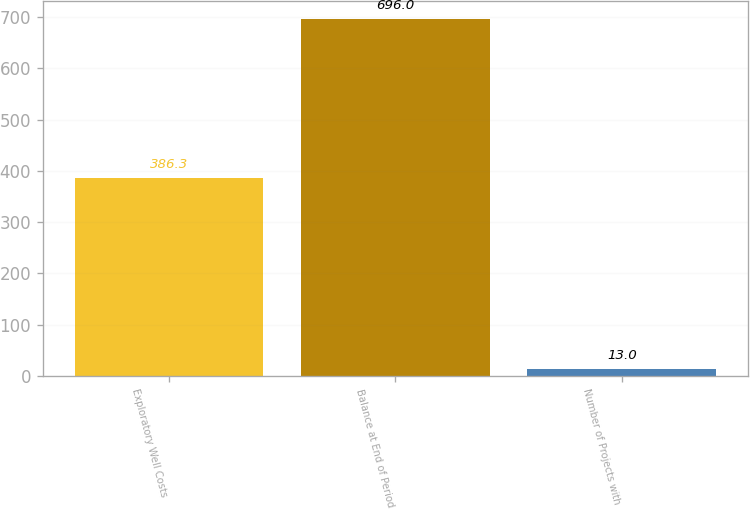Convert chart. <chart><loc_0><loc_0><loc_500><loc_500><bar_chart><fcel>Exploratory Well Costs<fcel>Balance at End of Period<fcel>Number of Projects with<nl><fcel>386.3<fcel>696<fcel>13<nl></chart> 